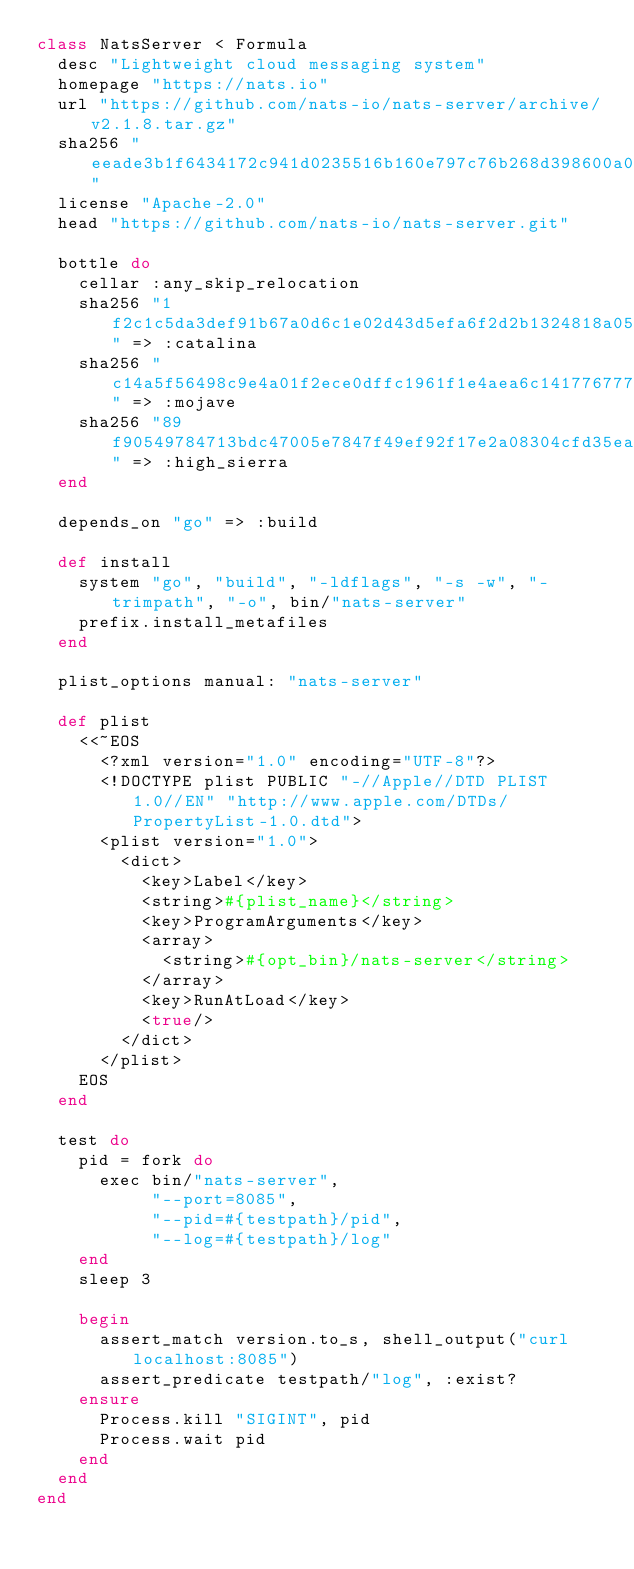<code> <loc_0><loc_0><loc_500><loc_500><_Ruby_>class NatsServer < Formula
  desc "Lightweight cloud messaging system"
  homepage "https://nats.io"
  url "https://github.com/nats-io/nats-server/archive/v2.1.8.tar.gz"
  sha256 "eeade3b1f6434172c941d0235516b160e797c76b268d398600a0d2286d971a31"
  license "Apache-2.0"
  head "https://github.com/nats-io/nats-server.git"

  bottle do
    cellar :any_skip_relocation
    sha256 "1f2c1c5da3def91b67a0d6c1e02d43d5efa6f2d2b1324818a05498f81ca2d45f" => :catalina
    sha256 "c14a5f56498c9e4a01f2ece0dffc1961f1e4aea6c1417767778931cf40aad7df" => :mojave
    sha256 "89f90549784713bdc47005e7847f49ef92f17e2a08304cfd35eacfbc74af0082" => :high_sierra
  end

  depends_on "go" => :build

  def install
    system "go", "build", "-ldflags", "-s -w", "-trimpath", "-o", bin/"nats-server"
    prefix.install_metafiles
  end

  plist_options manual: "nats-server"

  def plist
    <<~EOS
      <?xml version="1.0" encoding="UTF-8"?>
      <!DOCTYPE plist PUBLIC "-//Apple//DTD PLIST 1.0//EN" "http://www.apple.com/DTDs/PropertyList-1.0.dtd">
      <plist version="1.0">
        <dict>
          <key>Label</key>
          <string>#{plist_name}</string>
          <key>ProgramArguments</key>
          <array>
            <string>#{opt_bin}/nats-server</string>
          </array>
          <key>RunAtLoad</key>
          <true/>
        </dict>
      </plist>
    EOS
  end

  test do
    pid = fork do
      exec bin/"nats-server",
           "--port=8085",
           "--pid=#{testpath}/pid",
           "--log=#{testpath}/log"
    end
    sleep 3

    begin
      assert_match version.to_s, shell_output("curl localhost:8085")
      assert_predicate testpath/"log", :exist?
    ensure
      Process.kill "SIGINT", pid
      Process.wait pid
    end
  end
end
</code> 